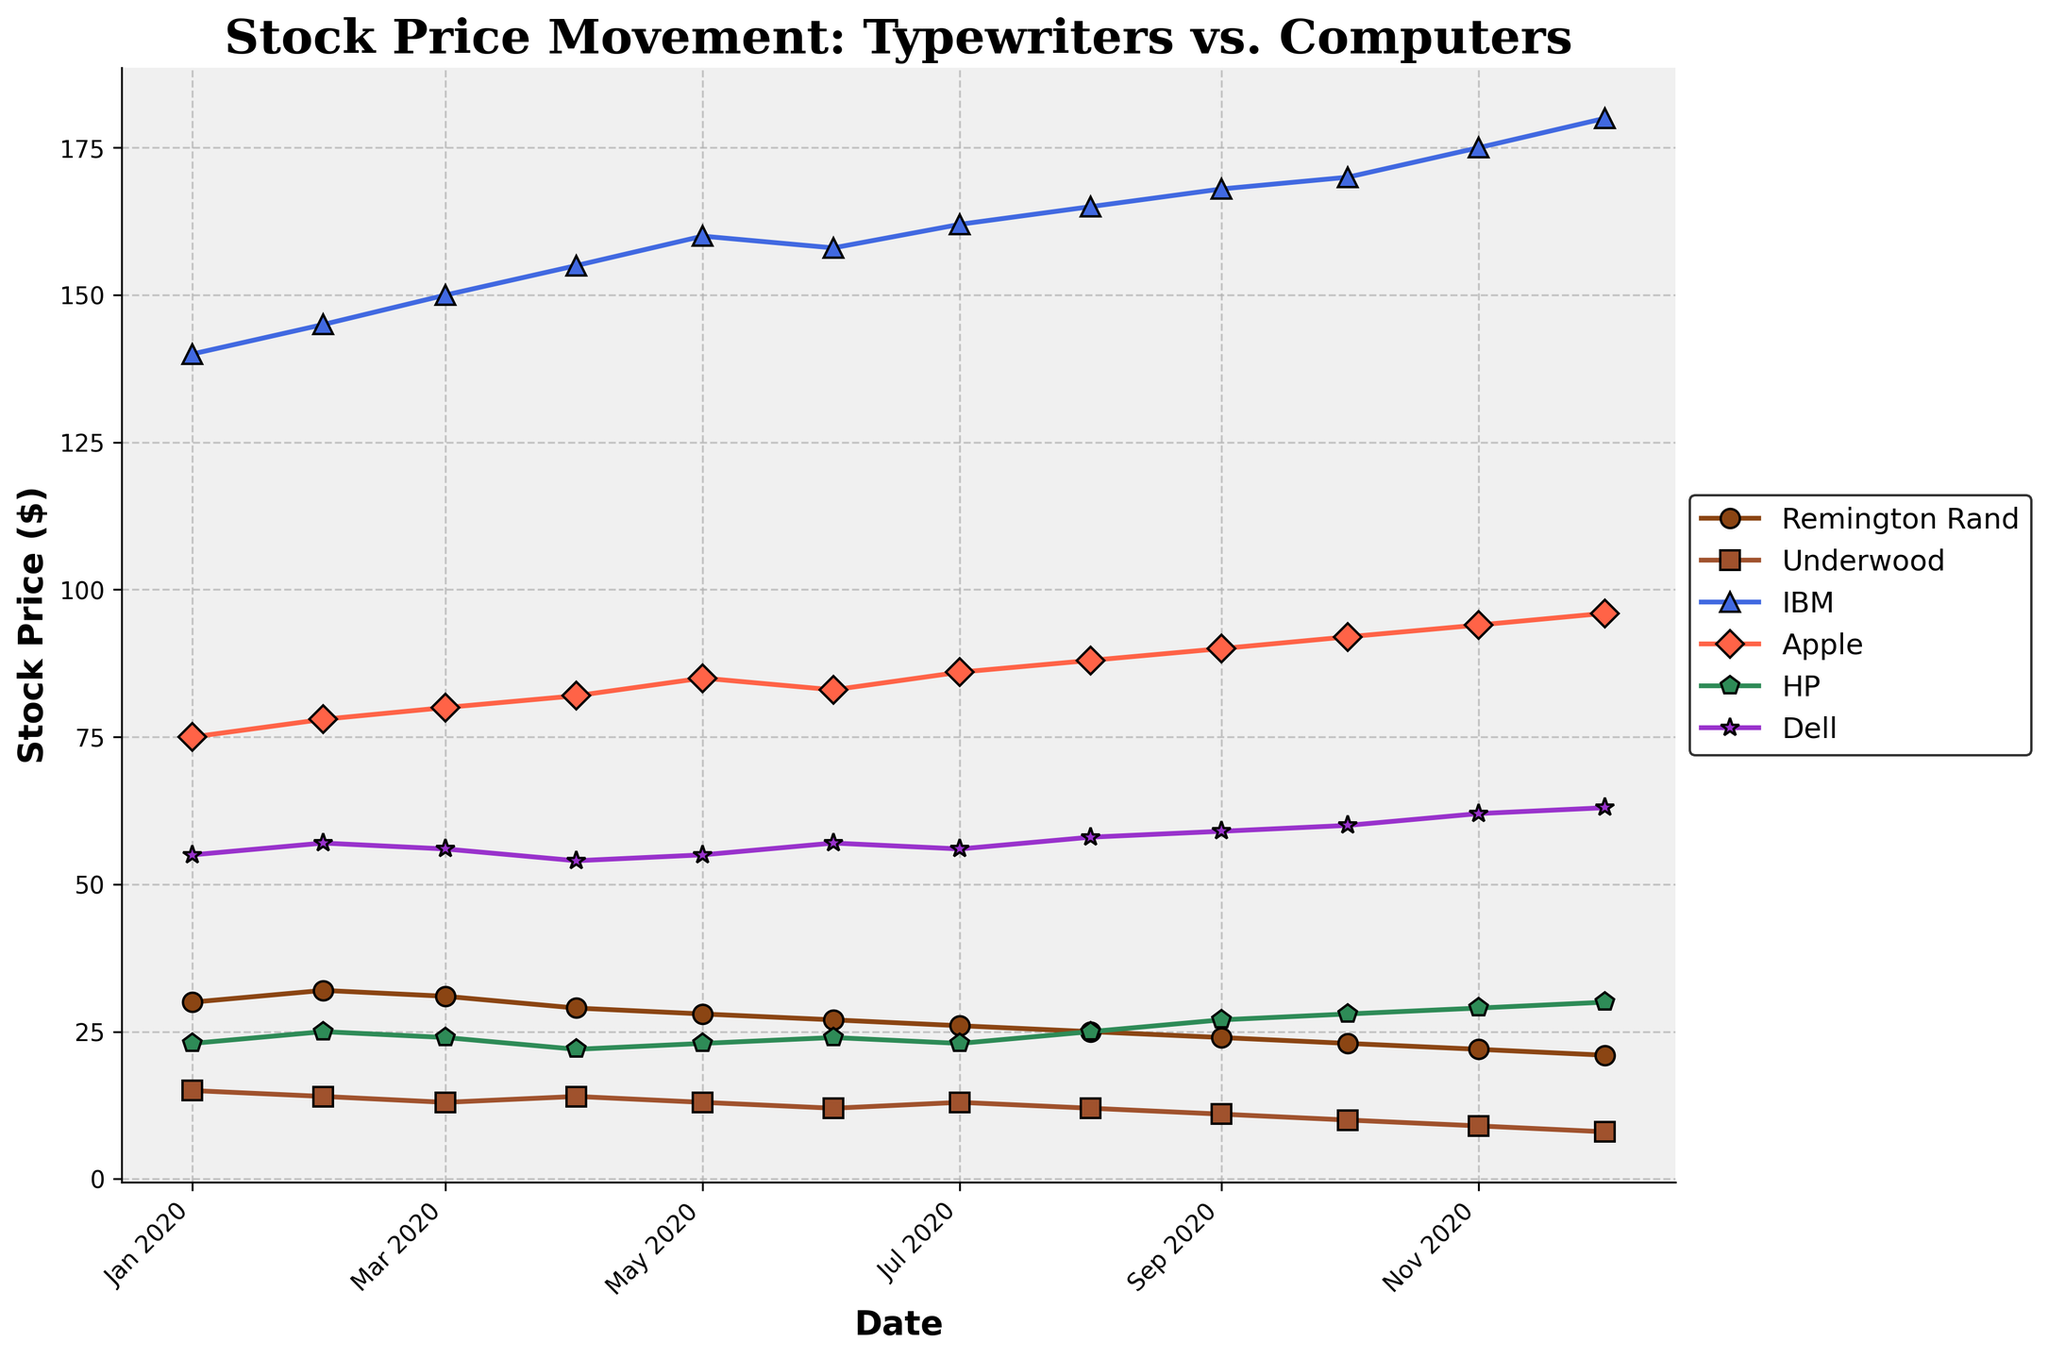What is the title of the plot? The title is displayed at the top of the figure, and it reads, "Stock Price Movement: Typewriters vs. Computers".
Answer: Stock Price Movement: Typewriters vs. Computers What is the color of the line representing IBM? The line representing IBM is the fourth in the order and is labeled with the company's name. The visual indication shows that this line is colored blue.
Answer: Blue How many data points are displayed for each company? Each company has data points for each month from January 2020 to December 2020, which totals 12 data points.
Answer: 12 Which company shows the highest stock price at any given point? Reviewing the stock prices of all companies over the given period, IBM consistently has the highest stock price. This is visible in the vertical positioning of its line.
Answer: IBM Did the stock price of Remington Rand increase or decrease over the year 2020? From a visual inspection of Remington Rand's line, it starts higher on the y-axis in January and ends lower in December, indicating a decrease.
Answer: Decrease Which month saw the highest stock price for Apple? The highest point for Apple's line is reached in December 2020, indicating that this is the month with the highest stock price on the plot.
Answer: December 2020 Compare the stock price change of Underwood and Dell between April 2020 and November 2020. How much did each change? For Underwood, the price changes from 14 in April to 9 in November, a decrease of 5. For Dell, the price changes from 54 in April to 62 in November, an increase of 8.
Answer: Underwood: -5, Dell: +8 Was there any month where all typewriter manufacturers had higher stock prices than all computer companies? By comparing the positions of the lines, at no point in time do the typewriter manufacturers (Remington Rand, Underwood) collectively surpass the stock prices of all computer companies (IBM, Apple, HP, Dell)
Answer: No Calculate the average stock price for Apple over the entire year. The sum of Apple's monthly stock prices from January 2020 to December 2020 is (75 + 78 + 80 + 82 + 85 + 83 + 86 + 88 + 90 + 92 + 94 + 96) = 1029. Dividing this by 12 gives an average of 85.75.
Answer: 85.75 